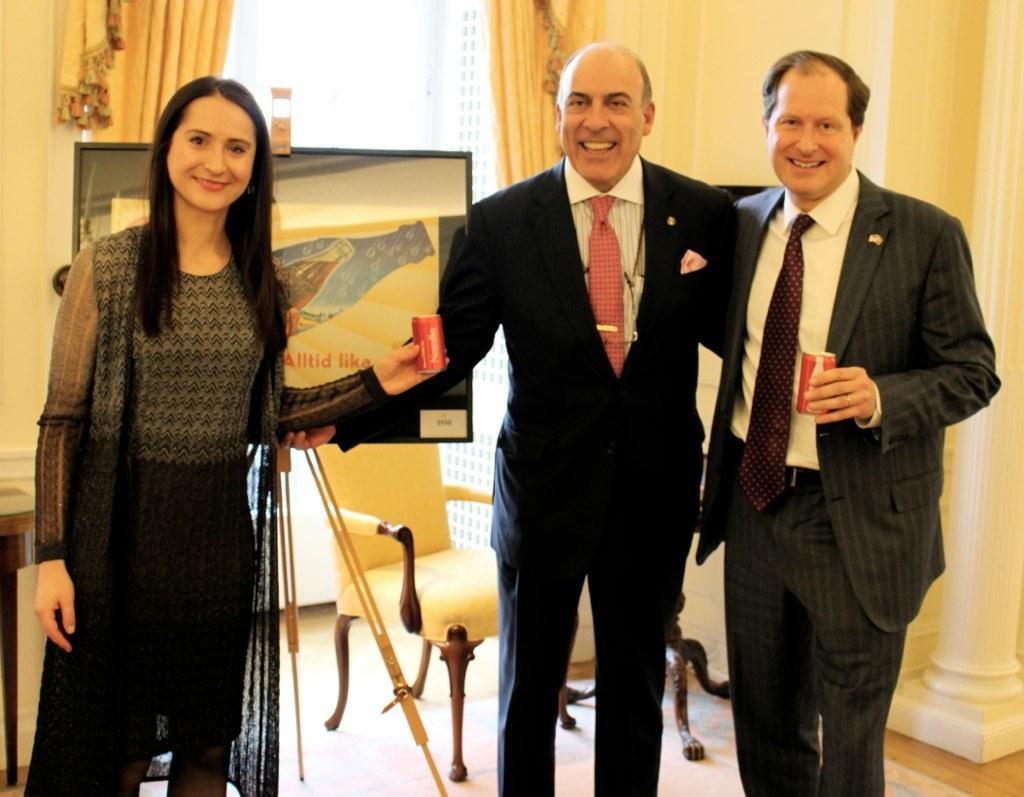In one or two sentences, can you explain what this image depicts? This is the picture of a room. In this image there are three persons standing and smiling and holding the objects. At the back there is a board on the stand and there is a chair and table and there are curtains. Behind the window there is a building. At the bottom there is a wooden floor. 